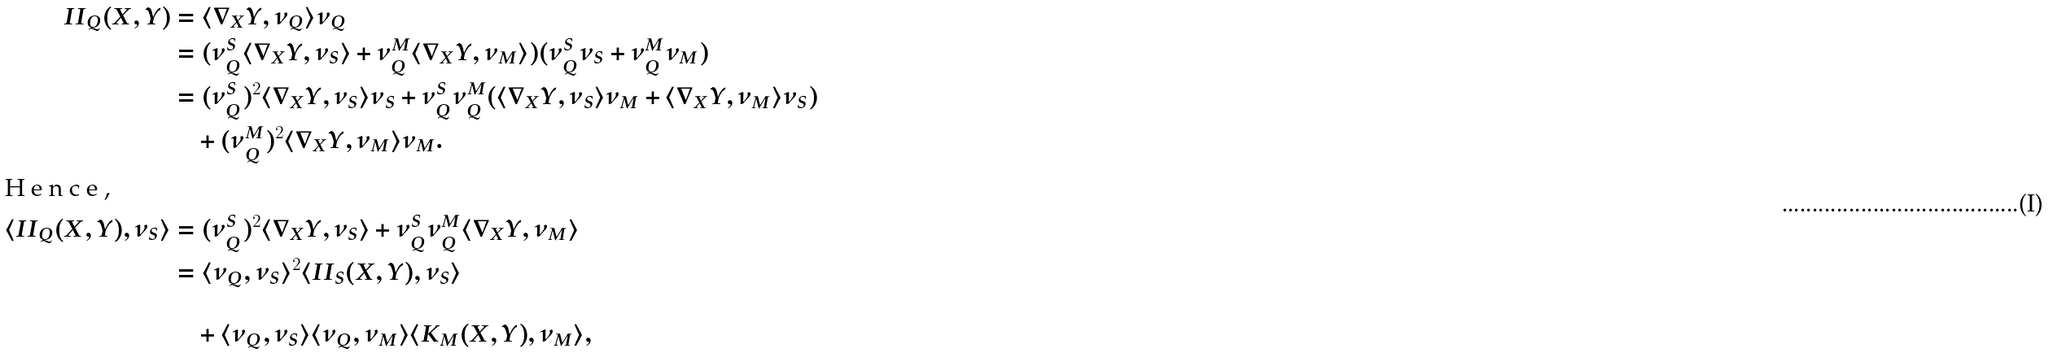Convert formula to latex. <formula><loc_0><loc_0><loc_500><loc_500>I I _ { Q } ( X , Y ) & = \langle \nabla _ { X } Y , \nu _ { Q } \rangle \nu _ { Q } \\ & = ( \nu _ { Q } ^ { S } \langle \nabla _ { X } Y , \nu _ { S } \rangle + \nu _ { Q } ^ { M } \langle \nabla _ { X } Y , \nu _ { M } \rangle ) ( \nu _ { Q } ^ { S } \nu _ { S } + \nu _ { Q } ^ { M } \nu _ { M } ) \\ & = ( \nu _ { Q } ^ { S } ) ^ { 2 } \langle \nabla _ { X } Y , \nu _ { S } \rangle \nu _ { S } + \nu _ { Q } ^ { S } \nu _ { Q } ^ { M } ( \langle \nabla _ { X } Y , \nu _ { S } \rangle \nu _ { M } + \langle \nabla _ { X } Y , \nu _ { M } \rangle \nu _ { S } ) \\ & \quad + ( \nu _ { Q } ^ { M } ) ^ { 2 } \langle \nabla _ { X } Y , \nu _ { M } \rangle \nu _ { M } . \\ \intertext { H e n c e , } \langle I I _ { Q } ( X , Y ) , \nu _ { S } \rangle & = ( \nu _ { Q } ^ { S } ) ^ { 2 } \langle \nabla _ { X } Y , \nu _ { S } \rangle + \nu _ { Q } ^ { S } \nu _ { Q } ^ { M } \langle \nabla _ { X } Y , \nu _ { M } \rangle \\ & = \langle \nu _ { Q } , \nu _ { S } \rangle ^ { 2 } \langle I I _ { S } ( X , Y ) , \nu _ { S } \rangle \\ \\ & \quad + \langle \nu _ { Q } , \nu _ { S } \rangle \langle \nu _ { Q } , \nu _ { M } \rangle \langle K _ { M } ( X , Y ) , \nu _ { M } \rangle ,</formula> 